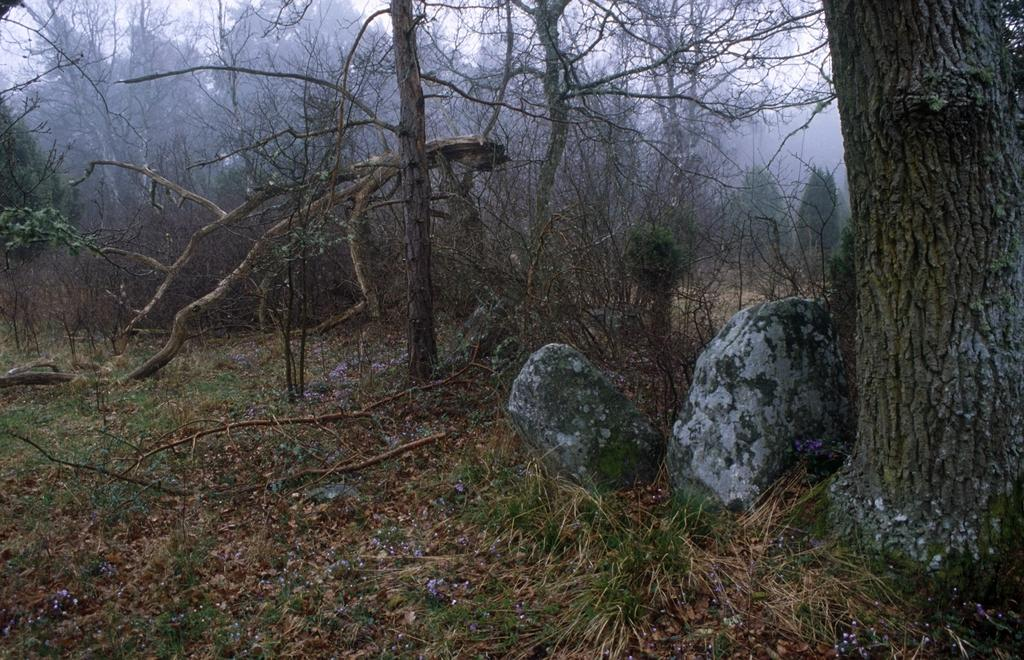What type of terrain is visible at the bottom of the picture? There is grass and rocks at the bottom of the picture. What can be seen in the background of the image? There are many trees in the background of the image. What type of environment might the image depict? The image might have been taken in a forest. What is the opinion of the clock in the image? There is no clock present in the image, so it is not possible to determine its opinion. 